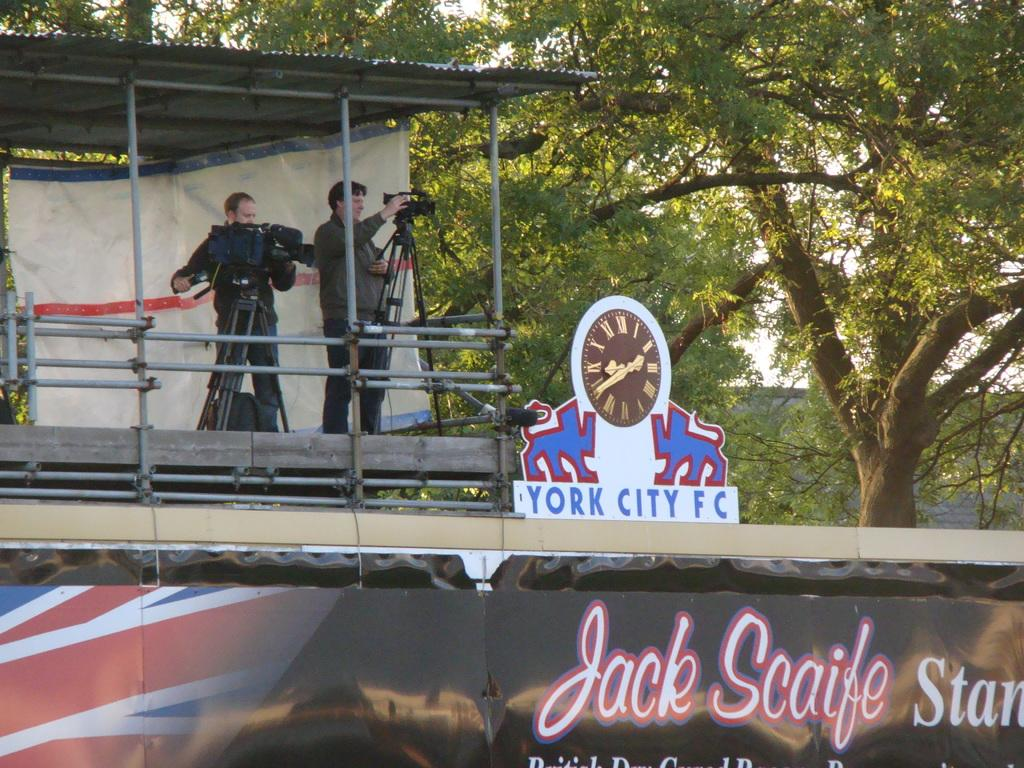<image>
Create a compact narrative representing the image presented. Two people recording video above a York City FC sign. 